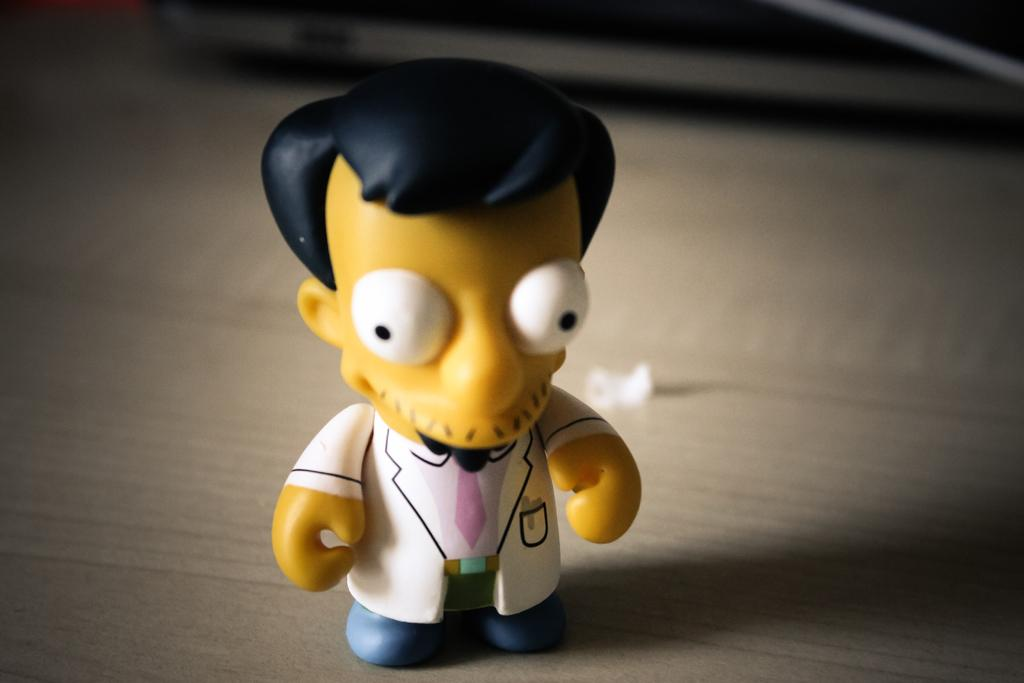What is the main subject of the image? There is a doll in the image. Where is the doll located in the image? The doll is placed on a surface. What type of operation is being performed on the doll in the image? There is no operation being performed on the doll in the image; it is simply placed on a surface. How many vans can be seen in the image? There are no vans present in the image. 